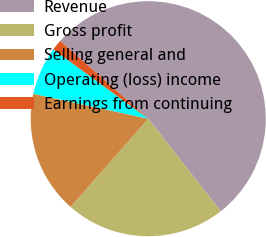Convert chart to OTSL. <chart><loc_0><loc_0><loc_500><loc_500><pie_chart><fcel>Revenue<fcel>Gross profit<fcel>Selling general and<fcel>Operating (loss) income<fcel>Earnings from continuing<nl><fcel>52.91%<fcel>22.06%<fcel>16.91%<fcel>6.63%<fcel>1.49%<nl></chart> 